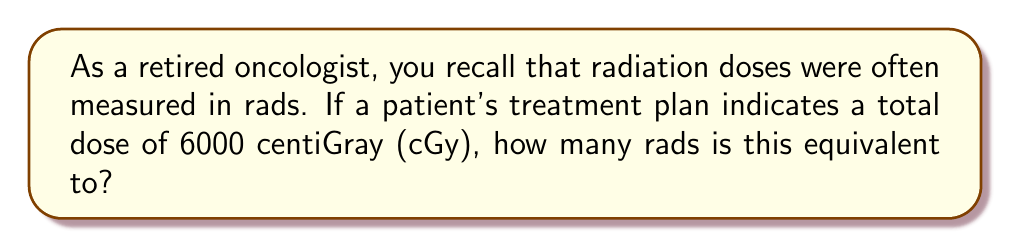Can you answer this question? To solve this problem, we need to follow these steps:

1) First, recall the conversion between Gray (Gy) and rad:
   1 Gy = 100 rad

2) The given dose is in centiGray (cGy). Let's convert this to Gray:
   $6000 \text{ cGy} = 60 \text{ Gy}$
   (because centi- means $\frac{1}{100}$, so 6000 cGy = $\frac{6000}{100}$ Gy = 60 Gy)

3) Now we can use the conversion factor from step 1:
   $60 \text{ Gy} \times \frac{100 \text{ rad}}{1 \text{ Gy}} = 6000 \text{ rad}$

Therefore, 6000 cGy is equivalent to 6000 rad.
Answer: 6000 rad 